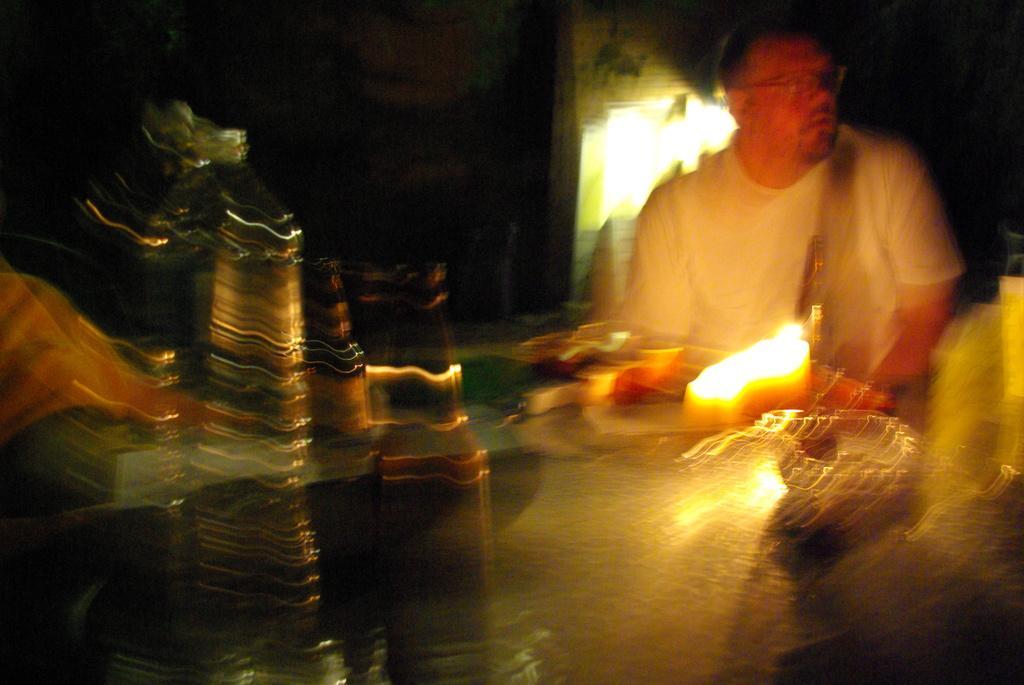Could you give a brief overview of what you see in this image? In this picture I can see a man seated and looks like few bottles and a bowl on the table and I can see light on the table and light on the back. 